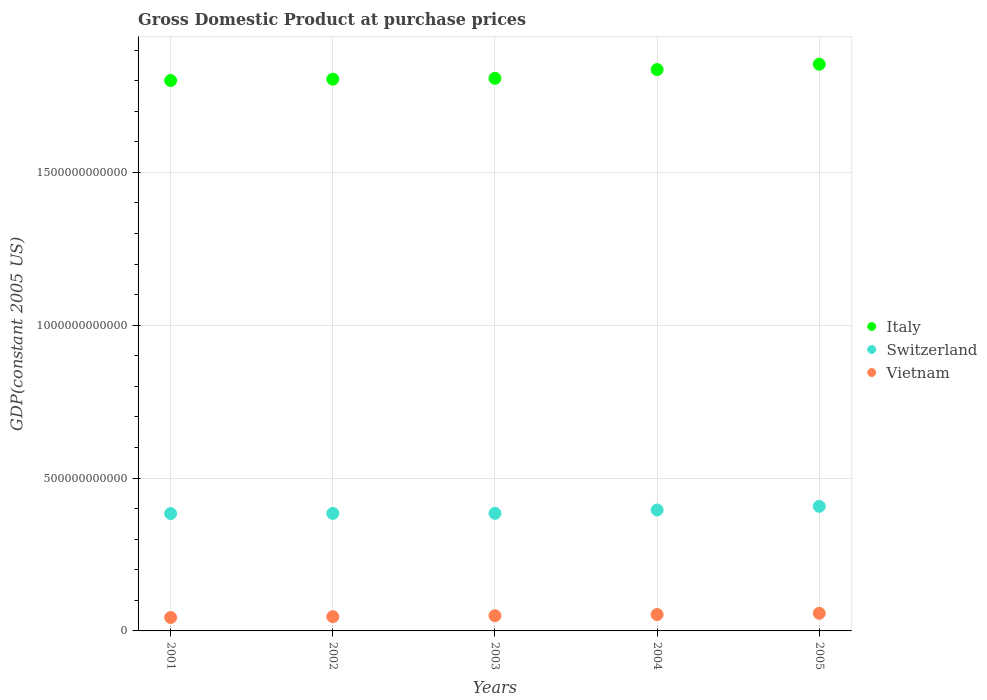How many different coloured dotlines are there?
Your response must be concise. 3. What is the GDP at purchase prices in Vietnam in 2004?
Offer a very short reply. 5.36e+1. Across all years, what is the maximum GDP at purchase prices in Italy?
Your answer should be very brief. 1.85e+12. Across all years, what is the minimum GDP at purchase prices in Switzerland?
Provide a short and direct response. 3.84e+11. In which year was the GDP at purchase prices in Italy maximum?
Your answer should be very brief. 2005. In which year was the GDP at purchase prices in Italy minimum?
Offer a terse response. 2001. What is the total GDP at purchase prices in Switzerland in the graph?
Provide a succinct answer. 1.96e+12. What is the difference between the GDP at purchase prices in Vietnam in 2003 and that in 2004?
Your response must be concise. -3.76e+09. What is the difference between the GDP at purchase prices in Vietnam in 2004 and the GDP at purchase prices in Switzerland in 2002?
Provide a succinct answer. -3.31e+11. What is the average GDP at purchase prices in Italy per year?
Give a very brief answer. 1.82e+12. In the year 2002, what is the difference between the GDP at purchase prices in Italy and GDP at purchase prices in Switzerland?
Your answer should be compact. 1.42e+12. In how many years, is the GDP at purchase prices in Switzerland greater than 600000000000 US$?
Your response must be concise. 0. What is the ratio of the GDP at purchase prices in Italy in 2002 to that in 2005?
Your answer should be compact. 0.97. What is the difference between the highest and the second highest GDP at purchase prices in Vietnam?
Ensure brevity in your answer.  4.04e+09. What is the difference between the highest and the lowest GDP at purchase prices in Italy?
Your response must be concise. 5.33e+1. Is the sum of the GDP at purchase prices in Switzerland in 2002 and 2003 greater than the maximum GDP at purchase prices in Italy across all years?
Give a very brief answer. No. Does the GDP at purchase prices in Italy monotonically increase over the years?
Give a very brief answer. Yes. How many years are there in the graph?
Offer a very short reply. 5. What is the difference between two consecutive major ticks on the Y-axis?
Give a very brief answer. 5.00e+11. Does the graph contain grids?
Your response must be concise. Yes. Where does the legend appear in the graph?
Keep it short and to the point. Center right. How many legend labels are there?
Keep it short and to the point. 3. What is the title of the graph?
Make the answer very short. Gross Domestic Product at purchase prices. What is the label or title of the X-axis?
Provide a short and direct response. Years. What is the label or title of the Y-axis?
Make the answer very short. GDP(constant 2005 US). What is the GDP(constant 2005 US) in Italy in 2001?
Your answer should be very brief. 1.80e+12. What is the GDP(constant 2005 US) of Switzerland in 2001?
Provide a succinct answer. 3.84e+11. What is the GDP(constant 2005 US) of Vietnam in 2001?
Provide a succinct answer. 4.38e+1. What is the GDP(constant 2005 US) of Italy in 2002?
Offer a terse response. 1.80e+12. What is the GDP(constant 2005 US) in Switzerland in 2002?
Your answer should be compact. 3.84e+11. What is the GDP(constant 2005 US) in Vietnam in 2002?
Offer a terse response. 4.66e+1. What is the GDP(constant 2005 US) of Italy in 2003?
Ensure brevity in your answer.  1.81e+12. What is the GDP(constant 2005 US) in Switzerland in 2003?
Your answer should be very brief. 3.85e+11. What is the GDP(constant 2005 US) in Vietnam in 2003?
Your answer should be very brief. 4.98e+1. What is the GDP(constant 2005 US) of Italy in 2004?
Your response must be concise. 1.84e+12. What is the GDP(constant 2005 US) in Switzerland in 2004?
Offer a terse response. 3.96e+11. What is the GDP(constant 2005 US) of Vietnam in 2004?
Your response must be concise. 5.36e+1. What is the GDP(constant 2005 US) of Italy in 2005?
Provide a succinct answer. 1.85e+12. What is the GDP(constant 2005 US) of Switzerland in 2005?
Your answer should be compact. 4.08e+11. What is the GDP(constant 2005 US) in Vietnam in 2005?
Provide a succinct answer. 5.76e+1. Across all years, what is the maximum GDP(constant 2005 US) in Italy?
Your response must be concise. 1.85e+12. Across all years, what is the maximum GDP(constant 2005 US) in Switzerland?
Make the answer very short. 4.08e+11. Across all years, what is the maximum GDP(constant 2005 US) of Vietnam?
Provide a succinct answer. 5.76e+1. Across all years, what is the minimum GDP(constant 2005 US) of Italy?
Offer a very short reply. 1.80e+12. Across all years, what is the minimum GDP(constant 2005 US) of Switzerland?
Your answer should be compact. 3.84e+11. Across all years, what is the minimum GDP(constant 2005 US) in Vietnam?
Your answer should be compact. 4.38e+1. What is the total GDP(constant 2005 US) of Italy in the graph?
Your answer should be compact. 9.10e+12. What is the total GDP(constant 2005 US) of Switzerland in the graph?
Your answer should be compact. 1.96e+12. What is the total GDP(constant 2005 US) of Vietnam in the graph?
Ensure brevity in your answer.  2.52e+11. What is the difference between the GDP(constant 2005 US) of Italy in 2001 and that in 2002?
Your response must be concise. -4.51e+09. What is the difference between the GDP(constant 2005 US) of Switzerland in 2001 and that in 2002?
Offer a terse response. -5.50e+08. What is the difference between the GDP(constant 2005 US) of Vietnam in 2001 and that in 2002?
Your response must be concise. -2.77e+09. What is the difference between the GDP(constant 2005 US) in Italy in 2001 and that in 2003?
Keep it short and to the point. -7.27e+09. What is the difference between the GDP(constant 2005 US) of Switzerland in 2001 and that in 2003?
Ensure brevity in your answer.  -7.41e+08. What is the difference between the GDP(constant 2005 US) in Vietnam in 2001 and that in 2003?
Make the answer very short. -5.99e+09. What is the difference between the GDP(constant 2005 US) in Italy in 2001 and that in 2004?
Provide a succinct answer. -3.59e+1. What is the difference between the GDP(constant 2005 US) of Switzerland in 2001 and that in 2004?
Ensure brevity in your answer.  -1.17e+1. What is the difference between the GDP(constant 2005 US) of Vietnam in 2001 and that in 2004?
Offer a terse response. -9.74e+09. What is the difference between the GDP(constant 2005 US) of Italy in 2001 and that in 2005?
Provide a succinct answer. -5.33e+1. What is the difference between the GDP(constant 2005 US) of Switzerland in 2001 and that in 2005?
Offer a very short reply. -2.37e+1. What is the difference between the GDP(constant 2005 US) of Vietnam in 2001 and that in 2005?
Your answer should be very brief. -1.38e+1. What is the difference between the GDP(constant 2005 US) of Italy in 2002 and that in 2003?
Ensure brevity in your answer.  -2.75e+09. What is the difference between the GDP(constant 2005 US) of Switzerland in 2002 and that in 2003?
Ensure brevity in your answer.  -1.91e+08. What is the difference between the GDP(constant 2005 US) of Vietnam in 2002 and that in 2003?
Provide a succinct answer. -3.22e+09. What is the difference between the GDP(constant 2005 US) of Italy in 2002 and that in 2004?
Your response must be concise. -3.14e+1. What is the difference between the GDP(constant 2005 US) in Switzerland in 2002 and that in 2004?
Keep it short and to the point. -1.11e+1. What is the difference between the GDP(constant 2005 US) of Vietnam in 2002 and that in 2004?
Your response must be concise. -6.97e+09. What is the difference between the GDP(constant 2005 US) in Italy in 2002 and that in 2005?
Provide a short and direct response. -4.88e+1. What is the difference between the GDP(constant 2005 US) in Switzerland in 2002 and that in 2005?
Keep it short and to the point. -2.31e+1. What is the difference between the GDP(constant 2005 US) of Vietnam in 2002 and that in 2005?
Keep it short and to the point. -1.10e+1. What is the difference between the GDP(constant 2005 US) in Italy in 2003 and that in 2004?
Your answer should be compact. -2.86e+1. What is the difference between the GDP(constant 2005 US) in Switzerland in 2003 and that in 2004?
Give a very brief answer. -1.09e+1. What is the difference between the GDP(constant 2005 US) in Vietnam in 2003 and that in 2004?
Your response must be concise. -3.76e+09. What is the difference between the GDP(constant 2005 US) in Italy in 2003 and that in 2005?
Provide a short and direct response. -4.61e+1. What is the difference between the GDP(constant 2005 US) of Switzerland in 2003 and that in 2005?
Offer a very short reply. -2.30e+1. What is the difference between the GDP(constant 2005 US) of Vietnam in 2003 and that in 2005?
Offer a very short reply. -7.80e+09. What is the difference between the GDP(constant 2005 US) in Italy in 2004 and that in 2005?
Offer a terse response. -1.74e+1. What is the difference between the GDP(constant 2005 US) of Switzerland in 2004 and that in 2005?
Give a very brief answer. -1.20e+1. What is the difference between the GDP(constant 2005 US) of Vietnam in 2004 and that in 2005?
Provide a short and direct response. -4.04e+09. What is the difference between the GDP(constant 2005 US) of Italy in 2001 and the GDP(constant 2005 US) of Switzerland in 2002?
Your answer should be very brief. 1.42e+12. What is the difference between the GDP(constant 2005 US) of Italy in 2001 and the GDP(constant 2005 US) of Vietnam in 2002?
Keep it short and to the point. 1.75e+12. What is the difference between the GDP(constant 2005 US) of Switzerland in 2001 and the GDP(constant 2005 US) of Vietnam in 2002?
Your response must be concise. 3.37e+11. What is the difference between the GDP(constant 2005 US) of Italy in 2001 and the GDP(constant 2005 US) of Switzerland in 2003?
Offer a terse response. 1.42e+12. What is the difference between the GDP(constant 2005 US) of Italy in 2001 and the GDP(constant 2005 US) of Vietnam in 2003?
Keep it short and to the point. 1.75e+12. What is the difference between the GDP(constant 2005 US) in Switzerland in 2001 and the GDP(constant 2005 US) in Vietnam in 2003?
Provide a short and direct response. 3.34e+11. What is the difference between the GDP(constant 2005 US) of Italy in 2001 and the GDP(constant 2005 US) of Switzerland in 2004?
Offer a very short reply. 1.40e+12. What is the difference between the GDP(constant 2005 US) of Italy in 2001 and the GDP(constant 2005 US) of Vietnam in 2004?
Provide a short and direct response. 1.75e+12. What is the difference between the GDP(constant 2005 US) in Switzerland in 2001 and the GDP(constant 2005 US) in Vietnam in 2004?
Give a very brief answer. 3.30e+11. What is the difference between the GDP(constant 2005 US) in Italy in 2001 and the GDP(constant 2005 US) in Switzerland in 2005?
Offer a very short reply. 1.39e+12. What is the difference between the GDP(constant 2005 US) of Italy in 2001 and the GDP(constant 2005 US) of Vietnam in 2005?
Keep it short and to the point. 1.74e+12. What is the difference between the GDP(constant 2005 US) of Switzerland in 2001 and the GDP(constant 2005 US) of Vietnam in 2005?
Give a very brief answer. 3.26e+11. What is the difference between the GDP(constant 2005 US) in Italy in 2002 and the GDP(constant 2005 US) in Switzerland in 2003?
Provide a short and direct response. 1.42e+12. What is the difference between the GDP(constant 2005 US) in Italy in 2002 and the GDP(constant 2005 US) in Vietnam in 2003?
Your response must be concise. 1.75e+12. What is the difference between the GDP(constant 2005 US) of Switzerland in 2002 and the GDP(constant 2005 US) of Vietnam in 2003?
Your answer should be very brief. 3.35e+11. What is the difference between the GDP(constant 2005 US) of Italy in 2002 and the GDP(constant 2005 US) of Switzerland in 2004?
Provide a succinct answer. 1.41e+12. What is the difference between the GDP(constant 2005 US) of Italy in 2002 and the GDP(constant 2005 US) of Vietnam in 2004?
Your response must be concise. 1.75e+12. What is the difference between the GDP(constant 2005 US) in Switzerland in 2002 and the GDP(constant 2005 US) in Vietnam in 2004?
Provide a succinct answer. 3.31e+11. What is the difference between the GDP(constant 2005 US) in Italy in 2002 and the GDP(constant 2005 US) in Switzerland in 2005?
Offer a very short reply. 1.40e+12. What is the difference between the GDP(constant 2005 US) in Italy in 2002 and the GDP(constant 2005 US) in Vietnam in 2005?
Your response must be concise. 1.75e+12. What is the difference between the GDP(constant 2005 US) in Switzerland in 2002 and the GDP(constant 2005 US) in Vietnam in 2005?
Make the answer very short. 3.27e+11. What is the difference between the GDP(constant 2005 US) of Italy in 2003 and the GDP(constant 2005 US) of Switzerland in 2004?
Provide a succinct answer. 1.41e+12. What is the difference between the GDP(constant 2005 US) in Italy in 2003 and the GDP(constant 2005 US) in Vietnam in 2004?
Your answer should be very brief. 1.75e+12. What is the difference between the GDP(constant 2005 US) in Switzerland in 2003 and the GDP(constant 2005 US) in Vietnam in 2004?
Your answer should be very brief. 3.31e+11. What is the difference between the GDP(constant 2005 US) of Italy in 2003 and the GDP(constant 2005 US) of Switzerland in 2005?
Give a very brief answer. 1.40e+12. What is the difference between the GDP(constant 2005 US) in Italy in 2003 and the GDP(constant 2005 US) in Vietnam in 2005?
Provide a succinct answer. 1.75e+12. What is the difference between the GDP(constant 2005 US) in Switzerland in 2003 and the GDP(constant 2005 US) in Vietnam in 2005?
Your response must be concise. 3.27e+11. What is the difference between the GDP(constant 2005 US) of Italy in 2004 and the GDP(constant 2005 US) of Switzerland in 2005?
Keep it short and to the point. 1.43e+12. What is the difference between the GDP(constant 2005 US) of Italy in 2004 and the GDP(constant 2005 US) of Vietnam in 2005?
Make the answer very short. 1.78e+12. What is the difference between the GDP(constant 2005 US) in Switzerland in 2004 and the GDP(constant 2005 US) in Vietnam in 2005?
Offer a terse response. 3.38e+11. What is the average GDP(constant 2005 US) of Italy per year?
Keep it short and to the point. 1.82e+12. What is the average GDP(constant 2005 US) of Switzerland per year?
Provide a short and direct response. 3.91e+11. What is the average GDP(constant 2005 US) in Vietnam per year?
Provide a succinct answer. 5.03e+1. In the year 2001, what is the difference between the GDP(constant 2005 US) in Italy and GDP(constant 2005 US) in Switzerland?
Offer a very short reply. 1.42e+12. In the year 2001, what is the difference between the GDP(constant 2005 US) in Italy and GDP(constant 2005 US) in Vietnam?
Provide a succinct answer. 1.76e+12. In the year 2001, what is the difference between the GDP(constant 2005 US) in Switzerland and GDP(constant 2005 US) in Vietnam?
Make the answer very short. 3.40e+11. In the year 2002, what is the difference between the GDP(constant 2005 US) in Italy and GDP(constant 2005 US) in Switzerland?
Offer a very short reply. 1.42e+12. In the year 2002, what is the difference between the GDP(constant 2005 US) of Italy and GDP(constant 2005 US) of Vietnam?
Your response must be concise. 1.76e+12. In the year 2002, what is the difference between the GDP(constant 2005 US) in Switzerland and GDP(constant 2005 US) in Vietnam?
Offer a terse response. 3.38e+11. In the year 2003, what is the difference between the GDP(constant 2005 US) of Italy and GDP(constant 2005 US) of Switzerland?
Provide a short and direct response. 1.42e+12. In the year 2003, what is the difference between the GDP(constant 2005 US) of Italy and GDP(constant 2005 US) of Vietnam?
Your response must be concise. 1.76e+12. In the year 2003, what is the difference between the GDP(constant 2005 US) in Switzerland and GDP(constant 2005 US) in Vietnam?
Offer a terse response. 3.35e+11. In the year 2004, what is the difference between the GDP(constant 2005 US) in Italy and GDP(constant 2005 US) in Switzerland?
Your answer should be very brief. 1.44e+12. In the year 2004, what is the difference between the GDP(constant 2005 US) in Italy and GDP(constant 2005 US) in Vietnam?
Provide a succinct answer. 1.78e+12. In the year 2004, what is the difference between the GDP(constant 2005 US) of Switzerland and GDP(constant 2005 US) of Vietnam?
Give a very brief answer. 3.42e+11. In the year 2005, what is the difference between the GDP(constant 2005 US) in Italy and GDP(constant 2005 US) in Switzerland?
Give a very brief answer. 1.45e+12. In the year 2005, what is the difference between the GDP(constant 2005 US) in Italy and GDP(constant 2005 US) in Vietnam?
Offer a terse response. 1.80e+12. In the year 2005, what is the difference between the GDP(constant 2005 US) of Switzerland and GDP(constant 2005 US) of Vietnam?
Provide a short and direct response. 3.50e+11. What is the ratio of the GDP(constant 2005 US) in Switzerland in 2001 to that in 2002?
Your answer should be very brief. 1. What is the ratio of the GDP(constant 2005 US) of Vietnam in 2001 to that in 2002?
Give a very brief answer. 0.94. What is the ratio of the GDP(constant 2005 US) in Switzerland in 2001 to that in 2003?
Offer a very short reply. 1. What is the ratio of the GDP(constant 2005 US) of Vietnam in 2001 to that in 2003?
Ensure brevity in your answer.  0.88. What is the ratio of the GDP(constant 2005 US) of Italy in 2001 to that in 2004?
Your answer should be compact. 0.98. What is the ratio of the GDP(constant 2005 US) in Switzerland in 2001 to that in 2004?
Your answer should be very brief. 0.97. What is the ratio of the GDP(constant 2005 US) in Vietnam in 2001 to that in 2004?
Your response must be concise. 0.82. What is the ratio of the GDP(constant 2005 US) of Italy in 2001 to that in 2005?
Your response must be concise. 0.97. What is the ratio of the GDP(constant 2005 US) in Switzerland in 2001 to that in 2005?
Ensure brevity in your answer.  0.94. What is the ratio of the GDP(constant 2005 US) in Vietnam in 2001 to that in 2005?
Your answer should be very brief. 0.76. What is the ratio of the GDP(constant 2005 US) in Switzerland in 2002 to that in 2003?
Your answer should be very brief. 1. What is the ratio of the GDP(constant 2005 US) in Vietnam in 2002 to that in 2003?
Keep it short and to the point. 0.94. What is the ratio of the GDP(constant 2005 US) in Italy in 2002 to that in 2004?
Provide a succinct answer. 0.98. What is the ratio of the GDP(constant 2005 US) of Switzerland in 2002 to that in 2004?
Give a very brief answer. 0.97. What is the ratio of the GDP(constant 2005 US) in Vietnam in 2002 to that in 2004?
Your answer should be compact. 0.87. What is the ratio of the GDP(constant 2005 US) in Italy in 2002 to that in 2005?
Offer a terse response. 0.97. What is the ratio of the GDP(constant 2005 US) in Switzerland in 2002 to that in 2005?
Offer a very short reply. 0.94. What is the ratio of the GDP(constant 2005 US) in Vietnam in 2002 to that in 2005?
Offer a terse response. 0.81. What is the ratio of the GDP(constant 2005 US) of Italy in 2003 to that in 2004?
Provide a short and direct response. 0.98. What is the ratio of the GDP(constant 2005 US) of Switzerland in 2003 to that in 2004?
Offer a terse response. 0.97. What is the ratio of the GDP(constant 2005 US) in Vietnam in 2003 to that in 2004?
Offer a terse response. 0.93. What is the ratio of the GDP(constant 2005 US) of Italy in 2003 to that in 2005?
Your answer should be very brief. 0.98. What is the ratio of the GDP(constant 2005 US) in Switzerland in 2003 to that in 2005?
Your response must be concise. 0.94. What is the ratio of the GDP(constant 2005 US) of Vietnam in 2003 to that in 2005?
Your answer should be compact. 0.86. What is the ratio of the GDP(constant 2005 US) of Italy in 2004 to that in 2005?
Provide a succinct answer. 0.99. What is the ratio of the GDP(constant 2005 US) in Switzerland in 2004 to that in 2005?
Your response must be concise. 0.97. What is the ratio of the GDP(constant 2005 US) in Vietnam in 2004 to that in 2005?
Give a very brief answer. 0.93. What is the difference between the highest and the second highest GDP(constant 2005 US) in Italy?
Make the answer very short. 1.74e+1. What is the difference between the highest and the second highest GDP(constant 2005 US) in Switzerland?
Offer a terse response. 1.20e+1. What is the difference between the highest and the second highest GDP(constant 2005 US) in Vietnam?
Provide a short and direct response. 4.04e+09. What is the difference between the highest and the lowest GDP(constant 2005 US) of Italy?
Your answer should be compact. 5.33e+1. What is the difference between the highest and the lowest GDP(constant 2005 US) in Switzerland?
Offer a terse response. 2.37e+1. What is the difference between the highest and the lowest GDP(constant 2005 US) in Vietnam?
Give a very brief answer. 1.38e+1. 